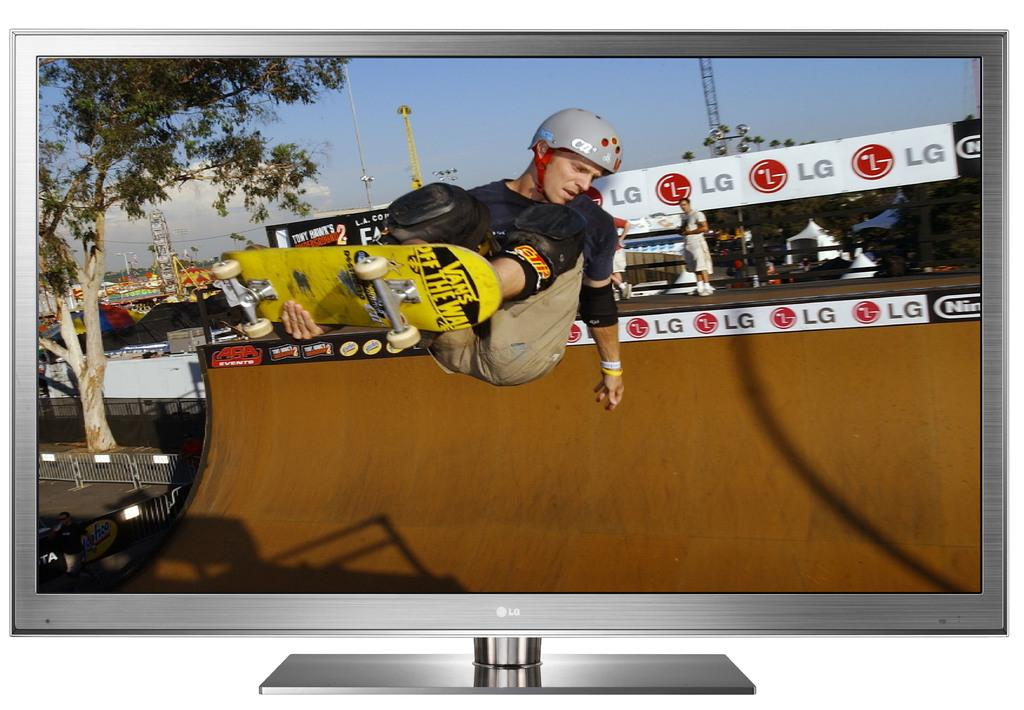<image>
Provide a brief description of the given image. a sign that has the name lg on it 